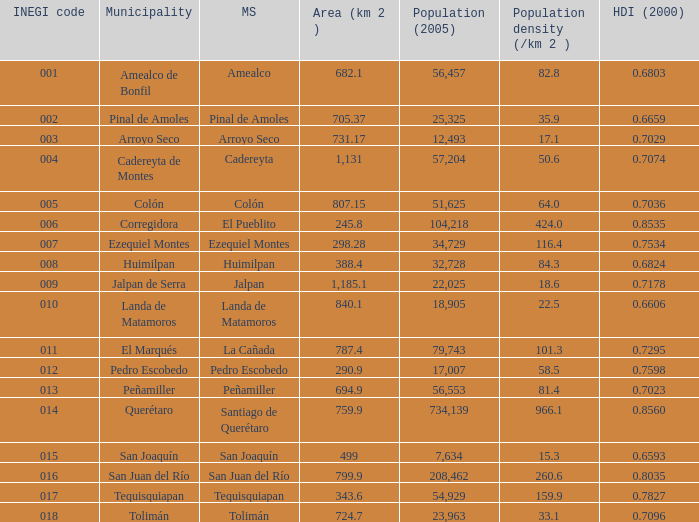Which Area (km 2 )has a Population (2005) of 57,204, and a Human Development Index (2000) smaller than 0.7074? 0.0. 